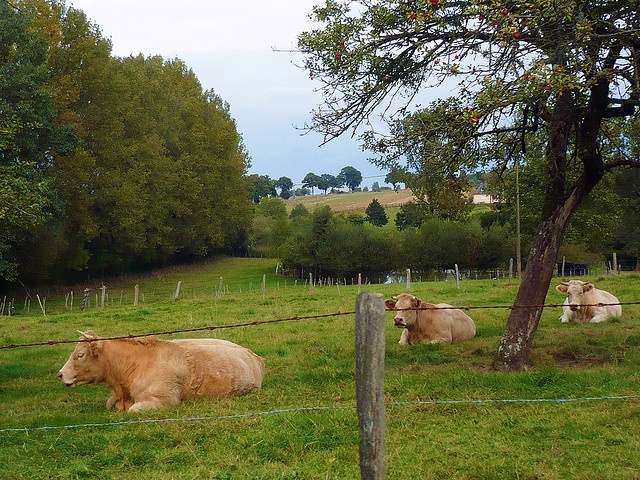Describe the objects in this image and their specific colors. I can see cow in darkgreen, brown, and tan tones, cow in darkgreen, gray, tan, olive, and maroon tones, and cow in darkgreen, tan, and olive tones in this image. 